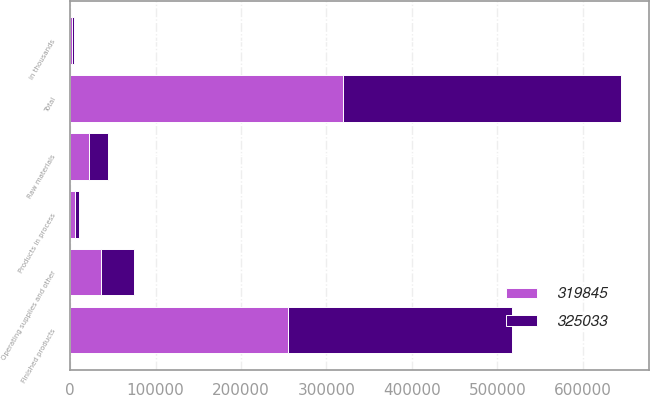<chart> <loc_0><loc_0><loc_500><loc_500><stacked_bar_chart><ecel><fcel>in thousands<fcel>Finished products<fcel>Raw materials<fcel>Products in process<fcel>Operating supplies and other<fcel>Total<nl><fcel>319845<fcel>2010<fcel>254840<fcel>22222<fcel>6036<fcel>36747<fcel>319845<nl><fcel>325033<fcel>2009<fcel>261752<fcel>21807<fcel>3907<fcel>37567<fcel>325033<nl></chart> 